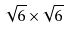Convert formula to latex. <formula><loc_0><loc_0><loc_500><loc_500>\sqrt { 6 } \times \sqrt { 6 }</formula> 